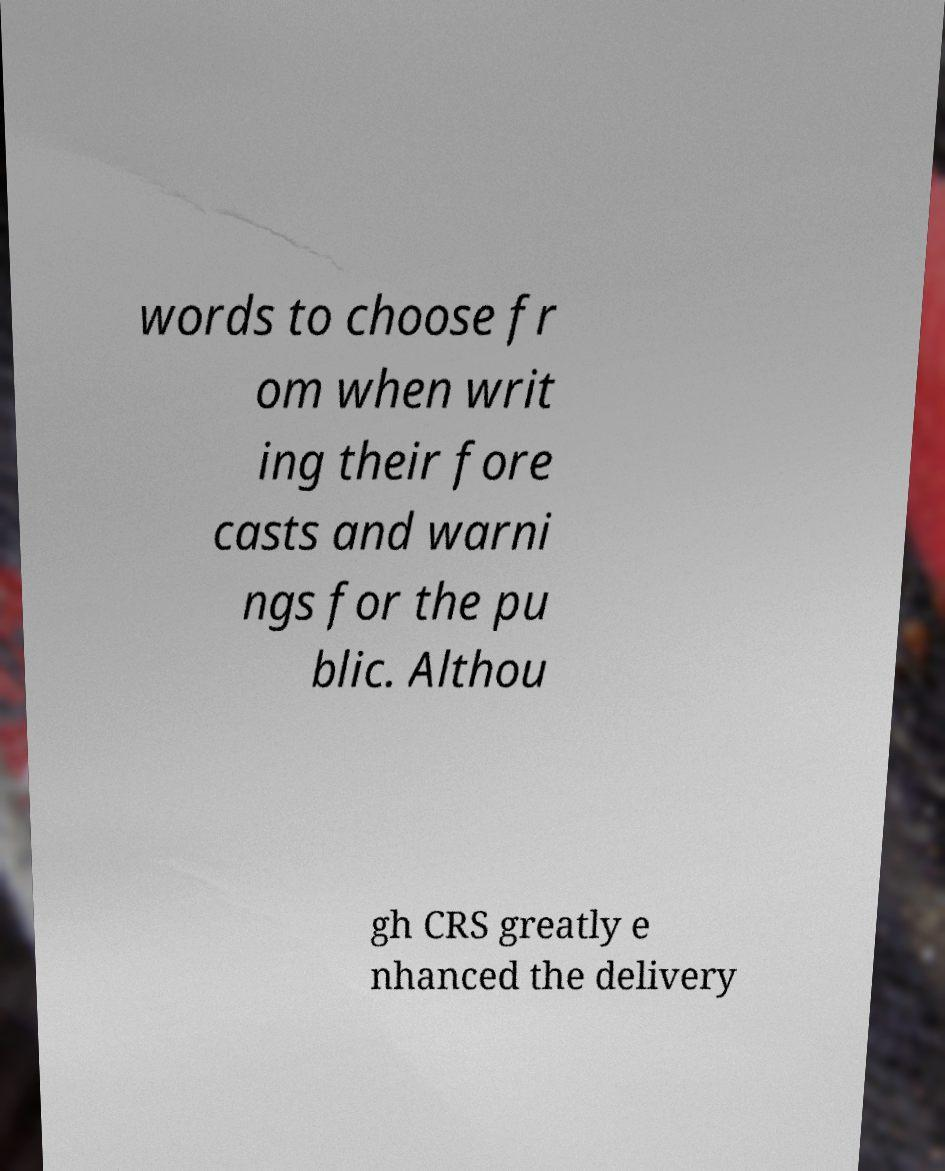Can you read and provide the text displayed in the image?This photo seems to have some interesting text. Can you extract and type it out for me? words to choose fr om when writ ing their fore casts and warni ngs for the pu blic. Althou gh CRS greatly e nhanced the delivery 